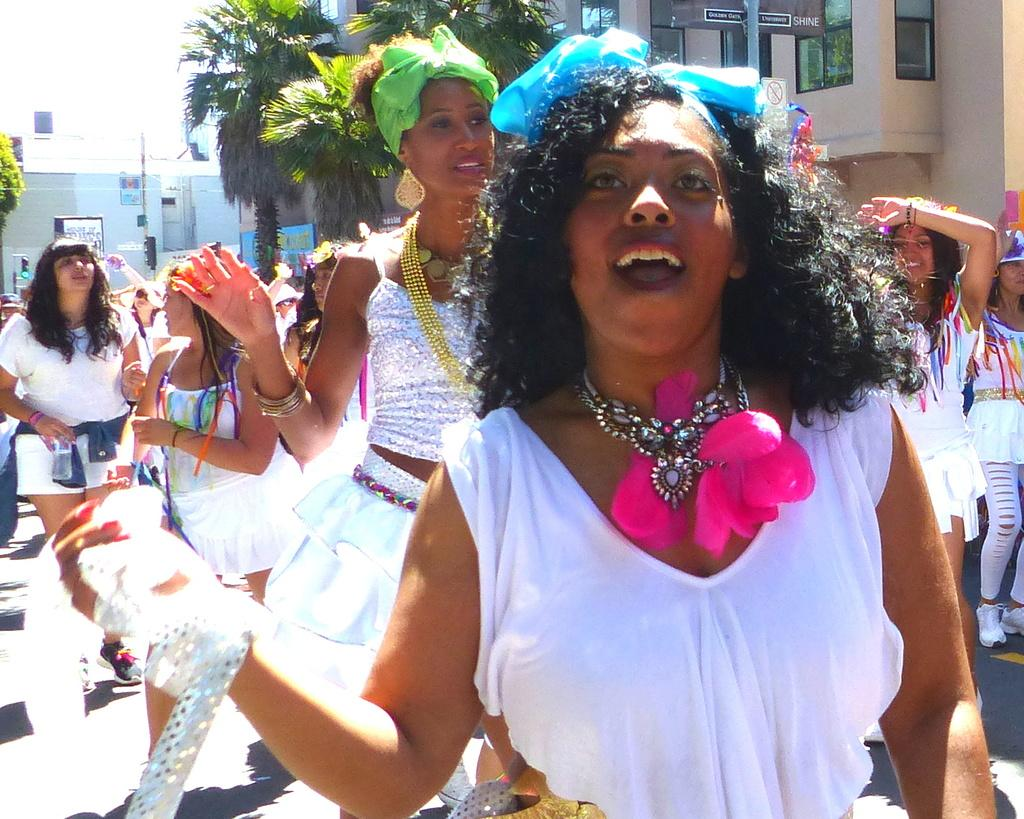What are the ladies in the image doing? The ladies in the image are performing dance. What can be seen in the background of the image? There are trees and buildings in the background of the image. What object is present in the image that might be used for support or decoration? There is a pole in the image. Can you see any fairies dancing with the ladies in the image? There are no fairies present in the image; only the ladies are performing dance. Is there a wave visible in the image? There is no wave visible in the image; it is a scene with ladies dancing, trees, and buildings in the background. 